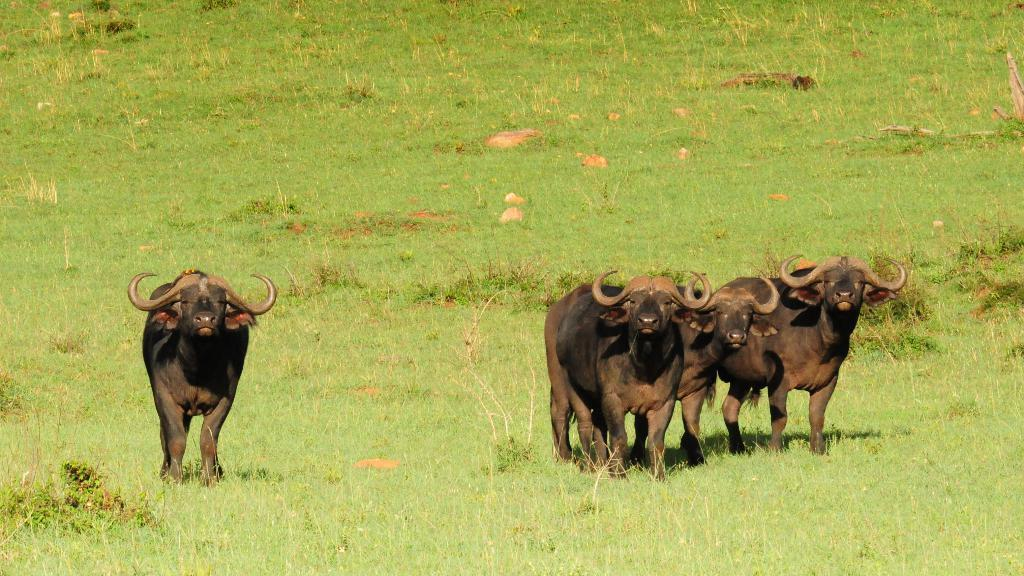What type of animals are in the image? There are black color bulls in the image. What is the background of the image? There is grass visible in the image. What type of trip did the bulls take to reach their current location in the image? There is no information about a trip or any movement of the bulls in the image. 